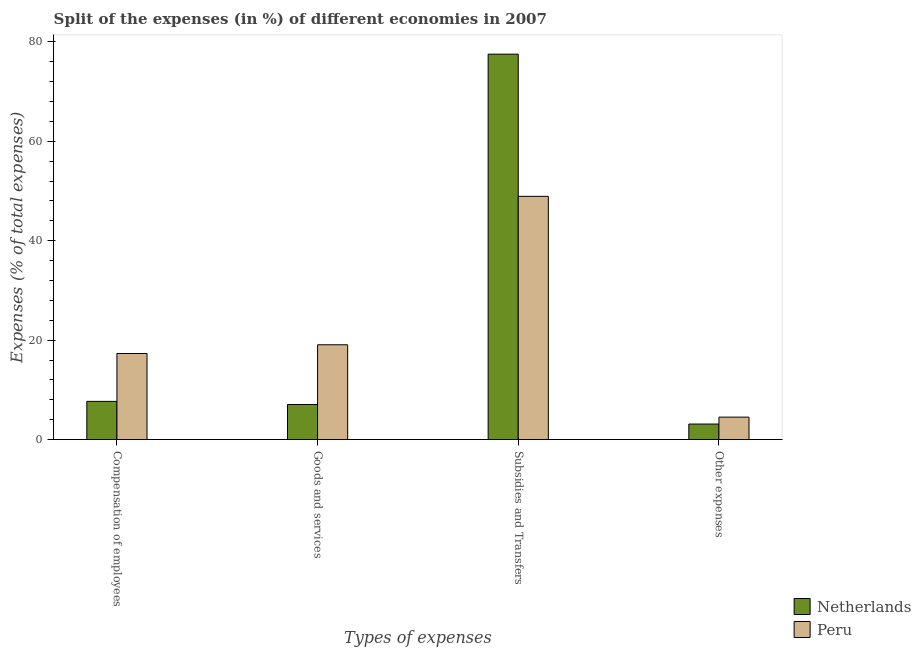Are the number of bars per tick equal to the number of legend labels?
Provide a short and direct response. Yes. How many bars are there on the 3rd tick from the left?
Your answer should be very brief. 2. What is the label of the 3rd group of bars from the left?
Give a very brief answer. Subsidies and Transfers. What is the percentage of amount spent on other expenses in Peru?
Provide a succinct answer. 4.52. Across all countries, what is the maximum percentage of amount spent on goods and services?
Provide a short and direct response. 19.08. Across all countries, what is the minimum percentage of amount spent on other expenses?
Provide a succinct answer. 3.13. What is the total percentage of amount spent on compensation of employees in the graph?
Ensure brevity in your answer.  25.01. What is the difference between the percentage of amount spent on goods and services in Peru and that in Netherlands?
Make the answer very short. 12.01. What is the difference between the percentage of amount spent on other expenses in Netherlands and the percentage of amount spent on compensation of employees in Peru?
Keep it short and to the point. -14.19. What is the average percentage of amount spent on goods and services per country?
Ensure brevity in your answer.  13.07. What is the difference between the percentage of amount spent on subsidies and percentage of amount spent on goods and services in Peru?
Your response must be concise. 29.86. In how many countries, is the percentage of amount spent on goods and services greater than 28 %?
Give a very brief answer. 0. What is the ratio of the percentage of amount spent on compensation of employees in Netherlands to that in Peru?
Ensure brevity in your answer.  0.44. What is the difference between the highest and the second highest percentage of amount spent on compensation of employees?
Offer a terse response. 9.63. What is the difference between the highest and the lowest percentage of amount spent on subsidies?
Offer a very short reply. 28.6. In how many countries, is the percentage of amount spent on other expenses greater than the average percentage of amount spent on other expenses taken over all countries?
Give a very brief answer. 1. Is it the case that in every country, the sum of the percentage of amount spent on subsidies and percentage of amount spent on goods and services is greater than the sum of percentage of amount spent on compensation of employees and percentage of amount spent on other expenses?
Offer a very short reply. Yes. What does the 1st bar from the right in Subsidies and Transfers represents?
Your answer should be compact. Peru. Is it the case that in every country, the sum of the percentage of amount spent on compensation of employees and percentage of amount spent on goods and services is greater than the percentage of amount spent on subsidies?
Give a very brief answer. No. How many bars are there?
Keep it short and to the point. 8. Are the values on the major ticks of Y-axis written in scientific E-notation?
Your response must be concise. No. Does the graph contain any zero values?
Your answer should be very brief. No. How are the legend labels stacked?
Keep it short and to the point. Vertical. What is the title of the graph?
Make the answer very short. Split of the expenses (in %) of different economies in 2007. What is the label or title of the X-axis?
Provide a succinct answer. Types of expenses. What is the label or title of the Y-axis?
Provide a succinct answer. Expenses (% of total expenses). What is the Expenses (% of total expenses) in Netherlands in Compensation of employees?
Keep it short and to the point. 7.69. What is the Expenses (% of total expenses) of Peru in Compensation of employees?
Ensure brevity in your answer.  17.32. What is the Expenses (% of total expenses) of Netherlands in Goods and services?
Your answer should be very brief. 7.06. What is the Expenses (% of total expenses) of Peru in Goods and services?
Your response must be concise. 19.08. What is the Expenses (% of total expenses) of Netherlands in Subsidies and Transfers?
Give a very brief answer. 77.54. What is the Expenses (% of total expenses) in Peru in Subsidies and Transfers?
Ensure brevity in your answer.  48.94. What is the Expenses (% of total expenses) in Netherlands in Other expenses?
Offer a terse response. 3.13. What is the Expenses (% of total expenses) of Peru in Other expenses?
Offer a very short reply. 4.52. Across all Types of expenses, what is the maximum Expenses (% of total expenses) in Netherlands?
Your response must be concise. 77.54. Across all Types of expenses, what is the maximum Expenses (% of total expenses) in Peru?
Offer a very short reply. 48.94. Across all Types of expenses, what is the minimum Expenses (% of total expenses) of Netherlands?
Make the answer very short. 3.13. Across all Types of expenses, what is the minimum Expenses (% of total expenses) of Peru?
Ensure brevity in your answer.  4.52. What is the total Expenses (% of total expenses) in Netherlands in the graph?
Ensure brevity in your answer.  95.42. What is the total Expenses (% of total expenses) in Peru in the graph?
Make the answer very short. 89.85. What is the difference between the Expenses (% of total expenses) in Netherlands in Compensation of employees and that in Goods and services?
Make the answer very short. 0.62. What is the difference between the Expenses (% of total expenses) of Peru in Compensation of employees and that in Goods and services?
Make the answer very short. -1.76. What is the difference between the Expenses (% of total expenses) of Netherlands in Compensation of employees and that in Subsidies and Transfers?
Keep it short and to the point. -69.85. What is the difference between the Expenses (% of total expenses) in Peru in Compensation of employees and that in Subsidies and Transfers?
Offer a very short reply. -31.62. What is the difference between the Expenses (% of total expenses) of Netherlands in Compensation of employees and that in Other expenses?
Offer a very short reply. 4.56. What is the difference between the Expenses (% of total expenses) of Peru in Compensation of employees and that in Other expenses?
Ensure brevity in your answer.  12.8. What is the difference between the Expenses (% of total expenses) of Netherlands in Goods and services and that in Subsidies and Transfers?
Provide a succinct answer. -70.47. What is the difference between the Expenses (% of total expenses) in Peru in Goods and services and that in Subsidies and Transfers?
Offer a terse response. -29.86. What is the difference between the Expenses (% of total expenses) of Netherlands in Goods and services and that in Other expenses?
Provide a succinct answer. 3.93. What is the difference between the Expenses (% of total expenses) in Peru in Goods and services and that in Other expenses?
Your answer should be very brief. 14.56. What is the difference between the Expenses (% of total expenses) of Netherlands in Subsidies and Transfers and that in Other expenses?
Your answer should be very brief. 74.41. What is the difference between the Expenses (% of total expenses) of Peru in Subsidies and Transfers and that in Other expenses?
Offer a terse response. 44.41. What is the difference between the Expenses (% of total expenses) in Netherlands in Compensation of employees and the Expenses (% of total expenses) in Peru in Goods and services?
Provide a succinct answer. -11.39. What is the difference between the Expenses (% of total expenses) of Netherlands in Compensation of employees and the Expenses (% of total expenses) of Peru in Subsidies and Transfers?
Offer a very short reply. -41.25. What is the difference between the Expenses (% of total expenses) in Netherlands in Compensation of employees and the Expenses (% of total expenses) in Peru in Other expenses?
Keep it short and to the point. 3.17. What is the difference between the Expenses (% of total expenses) of Netherlands in Goods and services and the Expenses (% of total expenses) of Peru in Subsidies and Transfers?
Make the answer very short. -41.87. What is the difference between the Expenses (% of total expenses) in Netherlands in Goods and services and the Expenses (% of total expenses) in Peru in Other expenses?
Your answer should be very brief. 2.54. What is the difference between the Expenses (% of total expenses) of Netherlands in Subsidies and Transfers and the Expenses (% of total expenses) of Peru in Other expenses?
Make the answer very short. 73.02. What is the average Expenses (% of total expenses) in Netherlands per Types of expenses?
Offer a terse response. 23.86. What is the average Expenses (% of total expenses) in Peru per Types of expenses?
Give a very brief answer. 22.46. What is the difference between the Expenses (% of total expenses) in Netherlands and Expenses (% of total expenses) in Peru in Compensation of employees?
Offer a terse response. -9.63. What is the difference between the Expenses (% of total expenses) in Netherlands and Expenses (% of total expenses) in Peru in Goods and services?
Provide a succinct answer. -12.01. What is the difference between the Expenses (% of total expenses) of Netherlands and Expenses (% of total expenses) of Peru in Subsidies and Transfers?
Give a very brief answer. 28.6. What is the difference between the Expenses (% of total expenses) of Netherlands and Expenses (% of total expenses) of Peru in Other expenses?
Offer a very short reply. -1.39. What is the ratio of the Expenses (% of total expenses) of Netherlands in Compensation of employees to that in Goods and services?
Provide a short and direct response. 1.09. What is the ratio of the Expenses (% of total expenses) in Peru in Compensation of employees to that in Goods and services?
Offer a terse response. 0.91. What is the ratio of the Expenses (% of total expenses) of Netherlands in Compensation of employees to that in Subsidies and Transfers?
Your answer should be very brief. 0.1. What is the ratio of the Expenses (% of total expenses) of Peru in Compensation of employees to that in Subsidies and Transfers?
Give a very brief answer. 0.35. What is the ratio of the Expenses (% of total expenses) of Netherlands in Compensation of employees to that in Other expenses?
Give a very brief answer. 2.46. What is the ratio of the Expenses (% of total expenses) of Peru in Compensation of employees to that in Other expenses?
Make the answer very short. 3.83. What is the ratio of the Expenses (% of total expenses) in Netherlands in Goods and services to that in Subsidies and Transfers?
Provide a short and direct response. 0.09. What is the ratio of the Expenses (% of total expenses) of Peru in Goods and services to that in Subsidies and Transfers?
Your answer should be compact. 0.39. What is the ratio of the Expenses (% of total expenses) of Netherlands in Goods and services to that in Other expenses?
Provide a short and direct response. 2.26. What is the ratio of the Expenses (% of total expenses) in Peru in Goods and services to that in Other expenses?
Offer a very short reply. 4.22. What is the ratio of the Expenses (% of total expenses) of Netherlands in Subsidies and Transfers to that in Other expenses?
Offer a very short reply. 24.76. What is the ratio of the Expenses (% of total expenses) in Peru in Subsidies and Transfers to that in Other expenses?
Give a very brief answer. 10.82. What is the difference between the highest and the second highest Expenses (% of total expenses) of Netherlands?
Give a very brief answer. 69.85. What is the difference between the highest and the second highest Expenses (% of total expenses) of Peru?
Make the answer very short. 29.86. What is the difference between the highest and the lowest Expenses (% of total expenses) in Netherlands?
Give a very brief answer. 74.41. What is the difference between the highest and the lowest Expenses (% of total expenses) of Peru?
Your answer should be very brief. 44.41. 